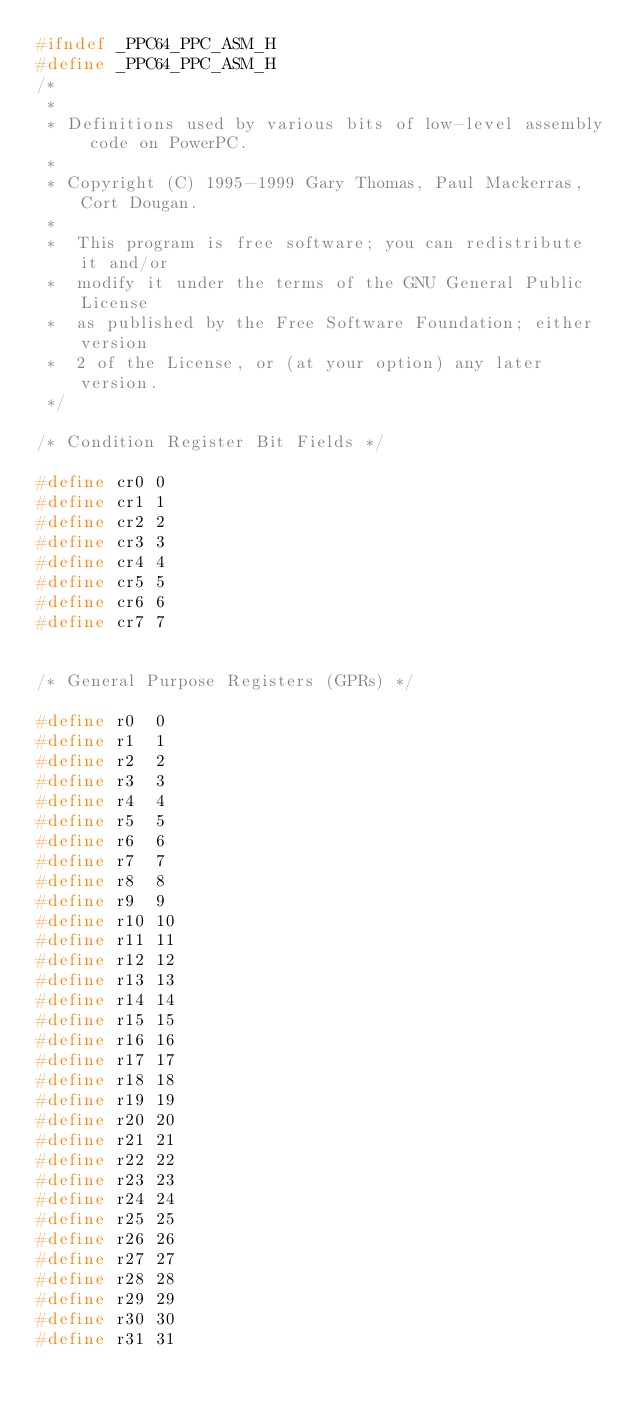<code> <loc_0><loc_0><loc_500><loc_500><_C_>#ifndef _PPC64_PPC_ASM_H
#define _PPC64_PPC_ASM_H
/*
 *
 * Definitions used by various bits of low-level assembly code on PowerPC.
 *
 * Copyright (C) 1995-1999 Gary Thomas, Paul Mackerras, Cort Dougan.
 *
 *  This program is free software; you can redistribute it and/or
 *  modify it under the terms of the GNU General Public License
 *  as published by the Free Software Foundation; either version
 *  2 of the License, or (at your option) any later version.
 */

/* Condition Register Bit Fields */

#define	cr0	0
#define	cr1	1
#define	cr2	2
#define	cr3	3
#define	cr4	4
#define	cr5	5
#define	cr6	6
#define	cr7	7


/* General Purpose Registers (GPRs) */

#define	r0	0
#define	r1	1
#define	r2	2
#define	r3	3
#define	r4	4
#define	r5	5
#define	r6	6
#define	r7	7
#define	r8	8
#define	r9	9
#define	r10	10
#define	r11	11
#define	r12	12
#define	r13	13
#define	r14	14
#define	r15	15
#define	r16	16
#define	r17	17
#define	r18	18
#define	r19	19
#define	r20	20
#define	r21	21
#define	r22	22
#define	r23	23
#define	r24	24
#define	r25	25
#define	r26	26
#define	r27	27
#define	r28	28
#define	r29	29
#define	r30	30
#define	r31	31
</code> 